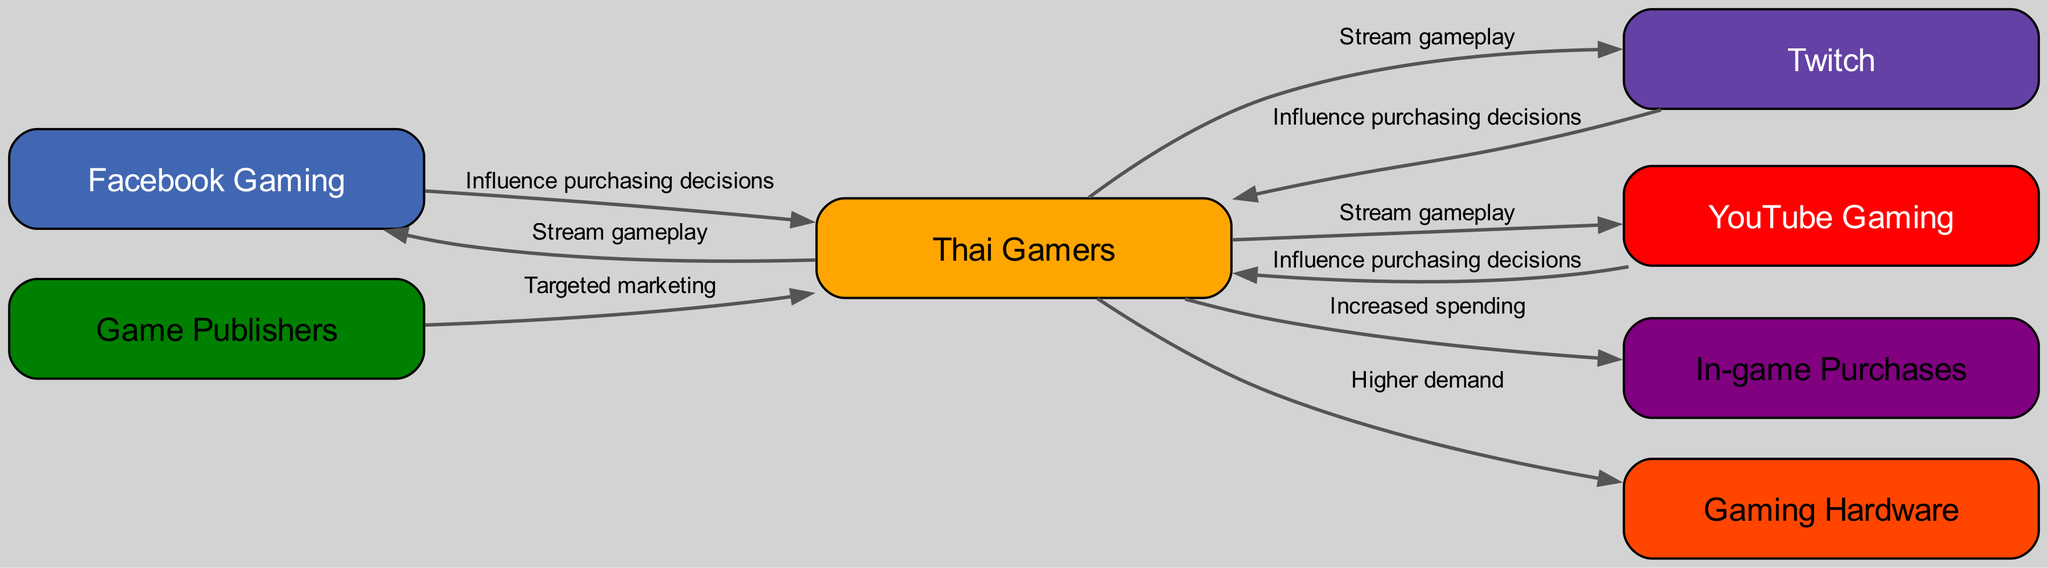What are the three platforms where Thai gamers stream gameplay? The diagram lists "Facebook Gaming," "Twitch," and "YouTube Gaming" as the platforms where Thai gamers stream their gameplay. These are directly connected to the "Thai Gamers" node indicating their engagement on these platforms.
Answer: Facebook Gaming, Twitch, YouTube Gaming How many nodes are in the diagram? By counting the unique entities represented in the diagram, there are a total of seven nodes: Facebook Gaming, Twitch, YouTube Gaming, Thai Gamers, Game Publishers, In-game Purchases, and Gaming Hardware.
Answer: 7 Which node influences purchasing decisions? The "Facebook Gaming," "Twitch," and "YouTube Gaming" nodes all have outgoing edges labeled "Influence purchasing decisions" connecting back to the "Thai Gamers" node, indicating that these platforms influence the purchasing decisions of gamers.
Answer: Facebook Gaming, Twitch, YouTube Gaming What is the relationship between "Thai Gamers" and "In-game Purchases"? The diagram shows a direct connection from "Thai Gamers" to "In-game Purchases" with the label "Increased spending," meaning that there is a relationship indicating that increased activity by gamers leads to higher spending on in-game purchases.
Answer: Increased spending What is the impact of "Game Publishers" on "Thai Gamers"? The diagram indicates that "Game Publishers" use "Targeted marketing" directed at the "Thai Gamers" node, suggesting that publishers shape the gaming experiences and choices of Thai gamers through strategic marketing efforts.
Answer: Targeted marketing How do Thai gamers affect the demand for "Gaming Hardware"? The diagram illustrates a direct link from "Thai Gamers" to "Gaming Hardware," marked as "Higher demand," which means the activities or preferences of Thai gamers contribute to a greater need for gaming hardware.
Answer: Higher demand What connects "Gaming Hardware" and "In-game Purchases"? The edges in the diagram do not explicitly connect "Gaming Hardware" and "In-game Purchases"; however, both nodes are influenced indirectly through the behaviors of "Thai Gamers." This indicates that both are related to the gaming ecosystem but not directly linked by an edge in the diagram.
Answer: No direct connection 